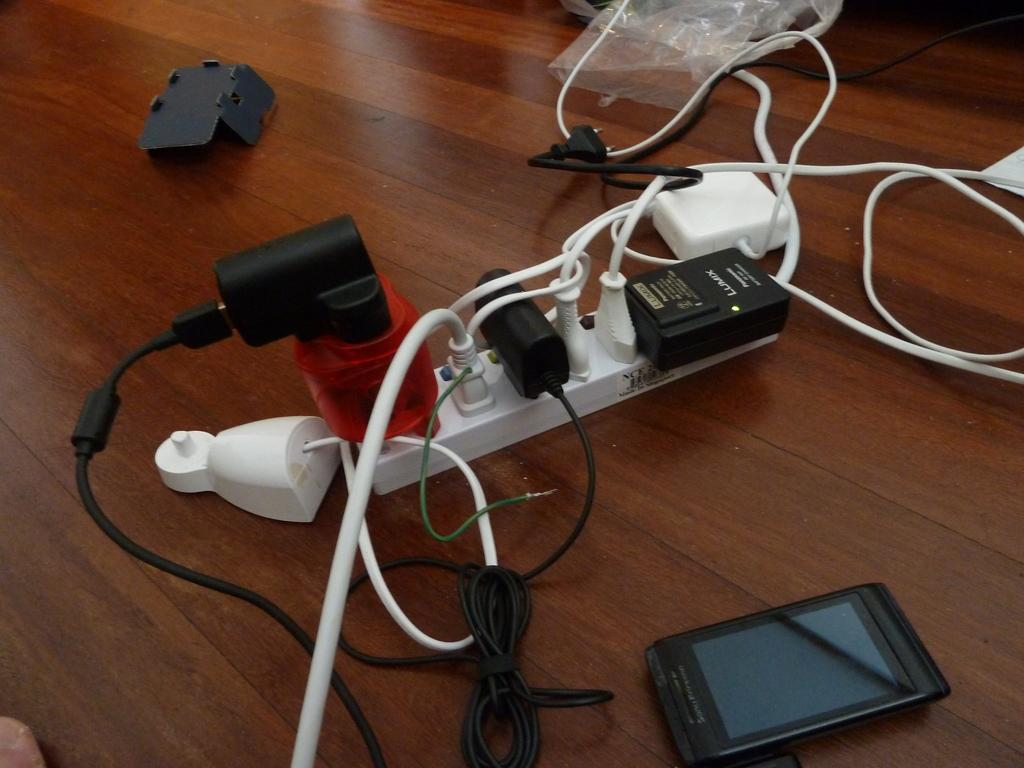What electronic device is visible in the image? There is a mobile phone in the image. What is connected to a power source in the image? Wires are connected to a socket in the image. What type of material is covering a wooden surface in the image? There is a polythene cover on a wooden surface in the image. What type of acoustics can be heard from the horse in the image? There is no horse present in the image, so it is not possible to determine the acoustics. 